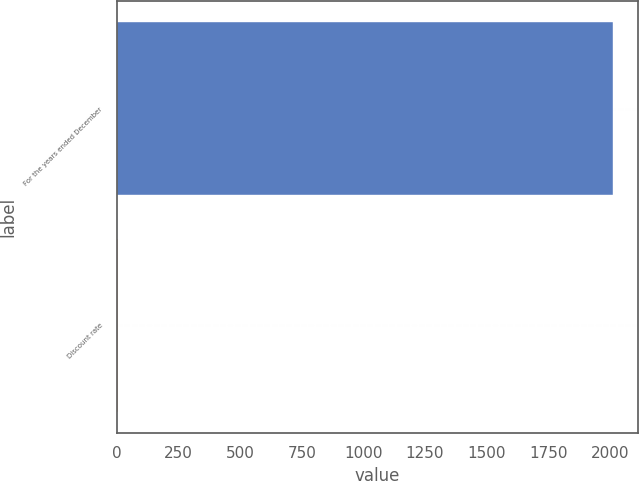Convert chart to OTSL. <chart><loc_0><loc_0><loc_500><loc_500><bar_chart><fcel>For the years ended December<fcel>Discount rate<nl><fcel>2012<fcel>4.5<nl></chart> 